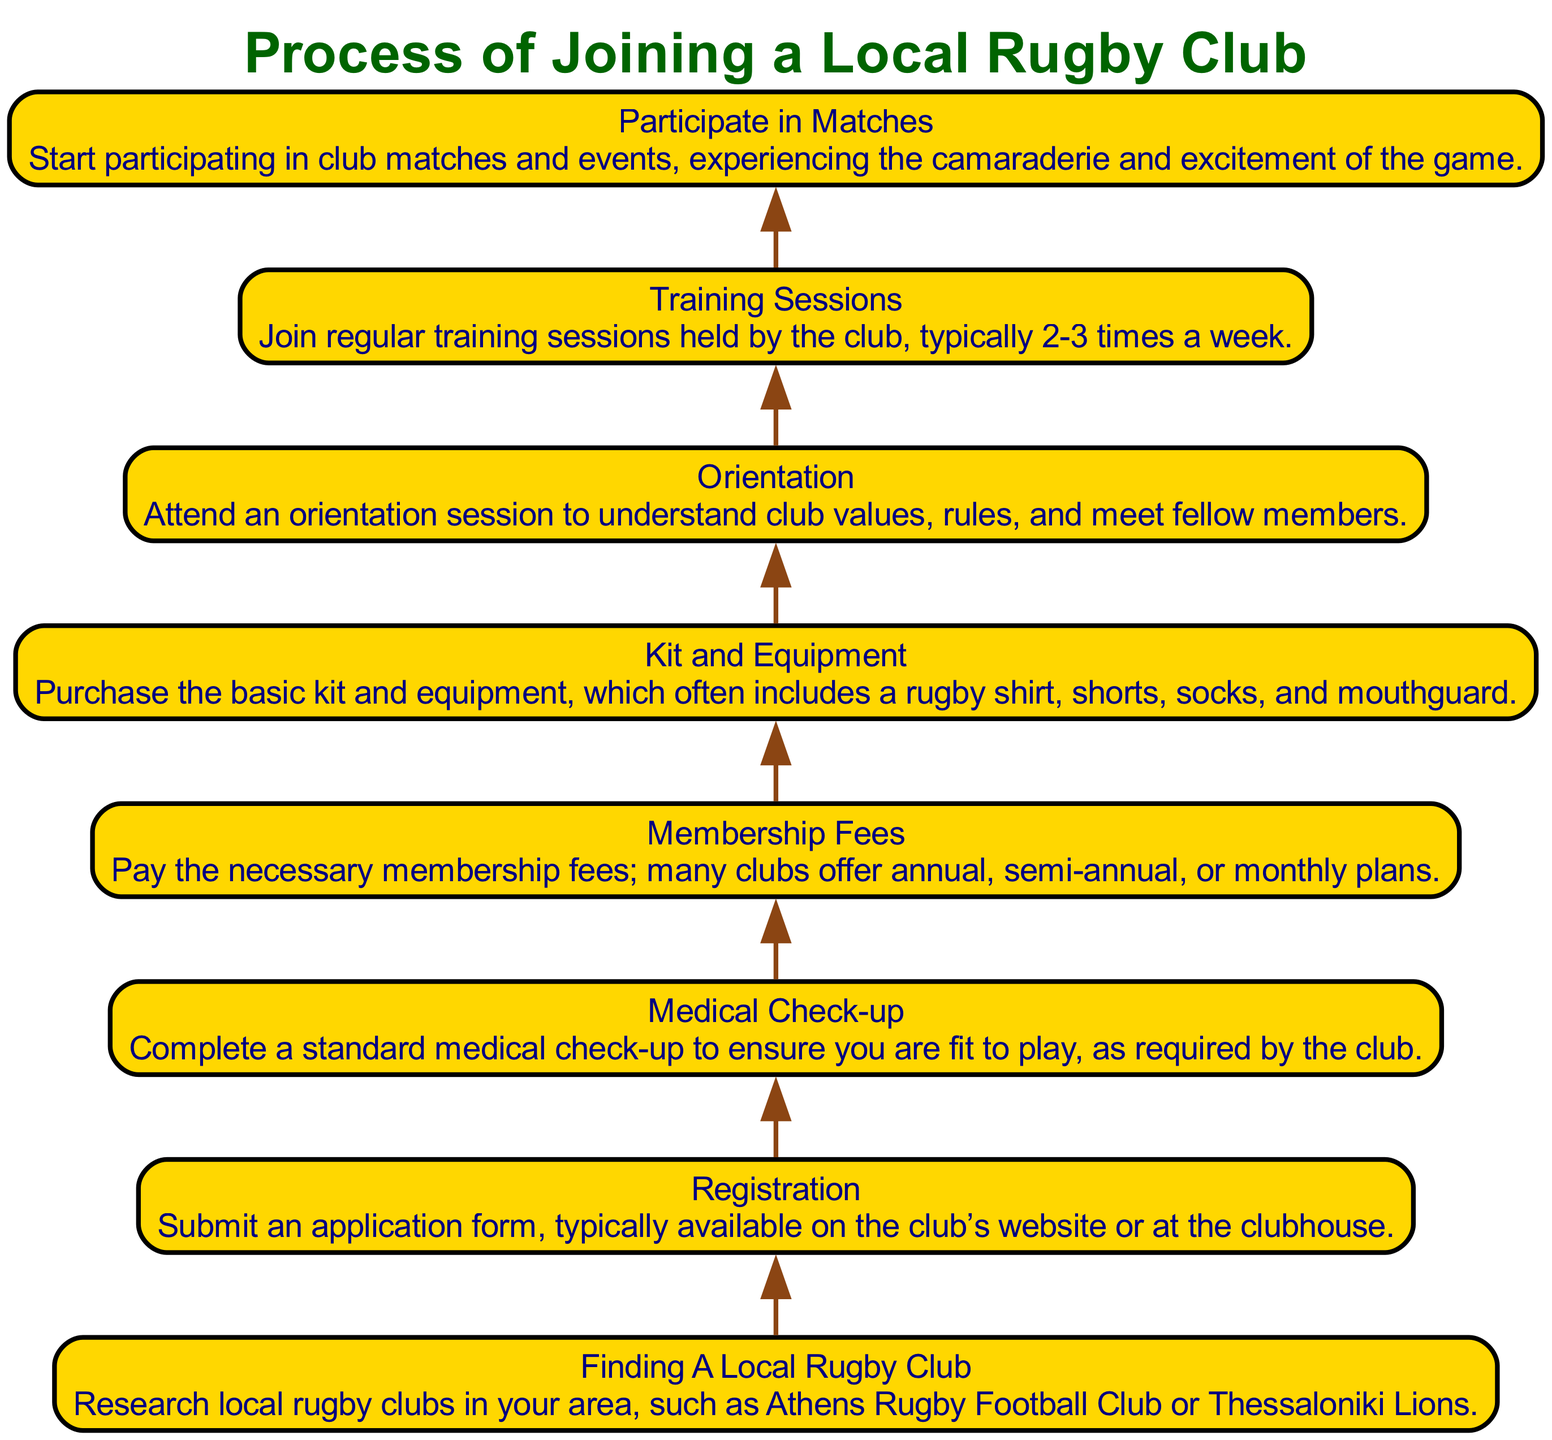What is the first step in joining a local rugby club? The first step according to the diagram is "Finding A Local Rugby Club", which involves researching local clubs in one's area. This is the starting point in the flow, indicated at the bottom of the diagram.
Answer: Finding A Local Rugby Club How many steps are there in the joining process? The diagram lists a total of eight steps in the joining process, ranging from finding a local club to participating in matches. This count can be determined by counting each distinct step in the flow.
Answer: Eight What must a person complete before registration? Before registration, a person must complete a "Medical Check-up" to ensure they are fit to play. This is indicated as a prerequisite step in the flow above the registration step.
Answer: Medical Check-up Which step comes after "Orientation"? The step that follows "Orientation" is "Training Sessions". This is determined by examining the flow from bottom to top and identifying the subsequent step in the diagram.
Answer: Training Sessions What are the necessary payments required in the joining process? The necessary payments required in the joining process are referred to as "Membership Fees", which involve paying the club's fees. This is noted as one of the key steps in the diagram.
Answer: Membership Fees How do participants experience camaraderie in the process? Participants experience camaraderie by "Participating in Matches", where they engage with fellow members in games and events. This step highlights the social aspect of joining a club, located at the top of the flow.
Answer: Participate in Matches What follows after handling the kit and equipment? Following handling the kit and equipment, the next step is "Orientation". This indicates how members first settle in with their equipment and then learn about club values and rules.
Answer: Orientation How often do training sessions typically occur? Training sessions typically occur "2-3 times a week". This frequency is highlighted in the details provided for the respective step in the diagram.
Answer: 2-3 times a week 